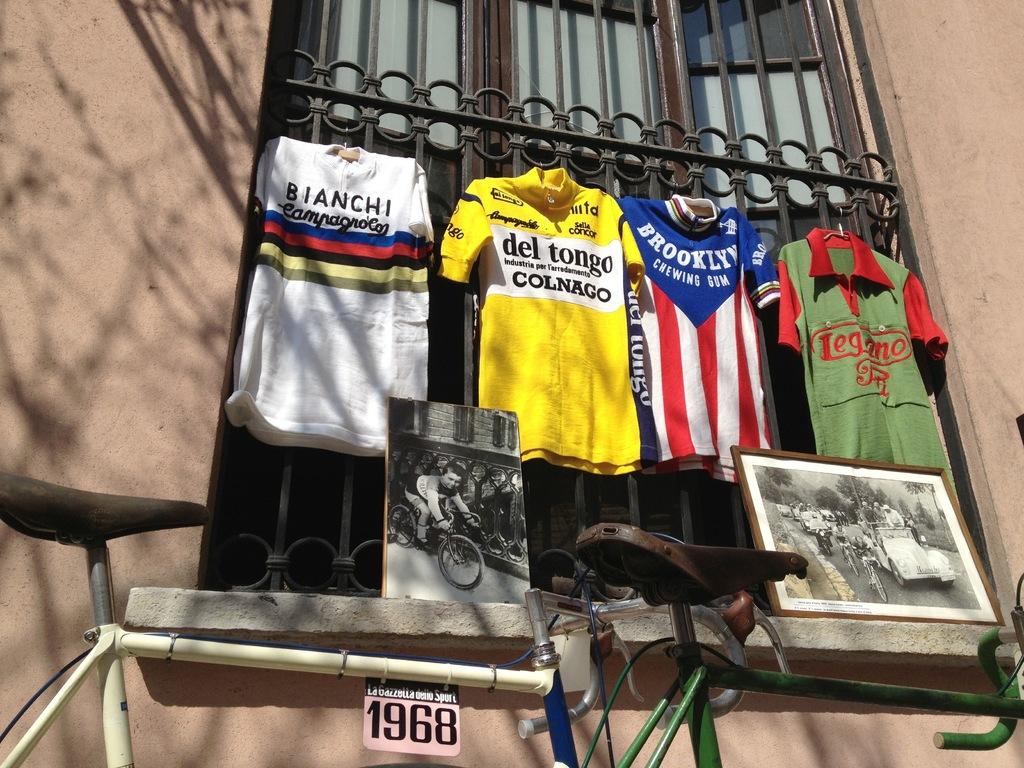What year is on the sign?
Ensure brevity in your answer.  1968. 